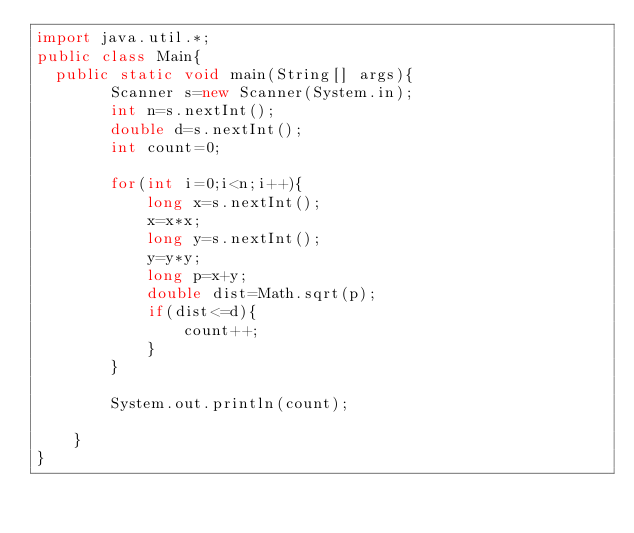<code> <loc_0><loc_0><loc_500><loc_500><_Java_>import java.util.*;
public class Main{
	public static void main(String[] args){
        Scanner s=new Scanner(System.in);
        int n=s.nextInt();
        double d=s.nextInt();
        int count=0;

        for(int i=0;i<n;i++){
            long x=s.nextInt();
            x=x*x;
            long y=s.nextInt();
            y=y*y;
            long p=x+y;
            double dist=Math.sqrt(p);
            if(dist<=d){
                count++;
            }
        }

        System.out.println(count);

    }
}</code> 